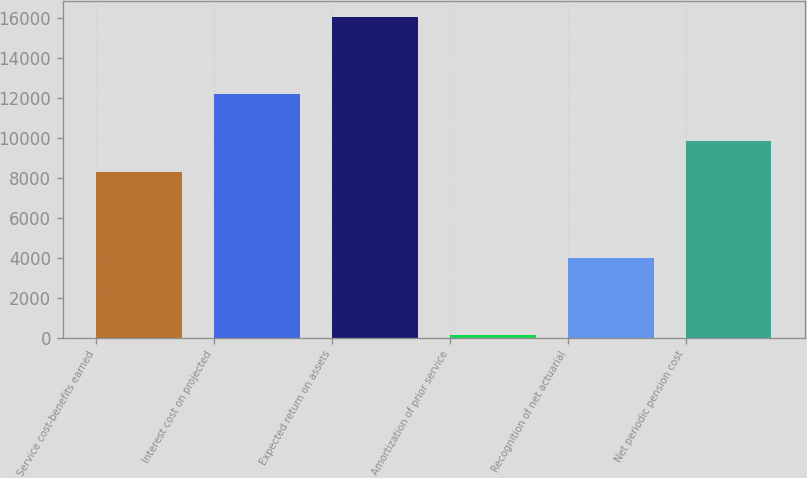Convert chart to OTSL. <chart><loc_0><loc_0><loc_500><loc_500><bar_chart><fcel>Service cost-benefits earned<fcel>Interest cost on projected<fcel>Expected return on assets<fcel>Amortization of prior service<fcel>Recognition of net actuarial<fcel>Net periodic pension cost<nl><fcel>8270<fcel>12200<fcel>16055<fcel>118<fcel>3981<fcel>9863.7<nl></chart> 